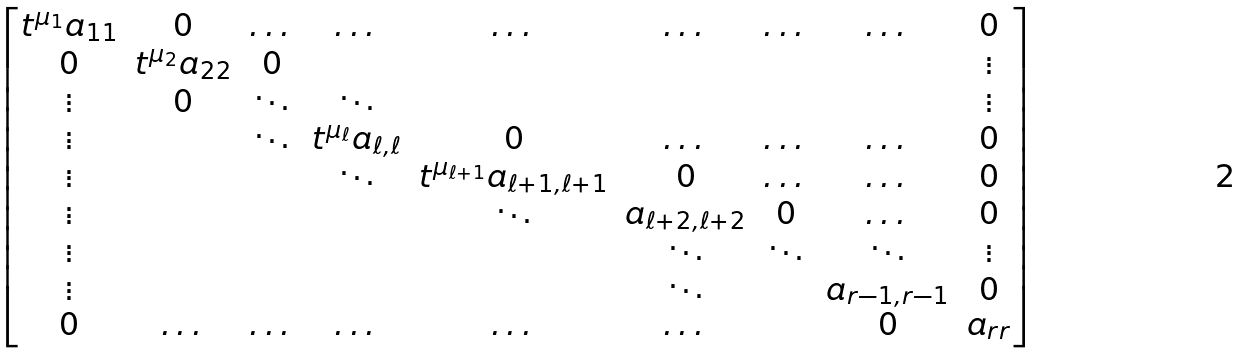<formula> <loc_0><loc_0><loc_500><loc_500>\begin{bmatrix} t ^ { \mu _ { 1 } } a _ { 1 1 } & 0 & \dots & \dots & \dots & \dots & \dots & \dots & 0 \\ 0 & t ^ { \mu _ { 2 } } a _ { 2 2 } & 0 & & & & & & \vdots \\ \vdots & 0 & \ddots & \ddots & & & & & \vdots \\ \vdots & & \ddots & t ^ { \mu _ { \ell } } a _ { \ell , \ell } & 0 & \dots & \dots & \dots & 0 \\ \vdots & & & \ddots & t ^ { \mu _ { \ell + 1 } } a _ { \ell + 1 , \ell + 1 } & 0 & \dots & \dots & 0 \\ \vdots & & & & \ddots & a _ { \ell + 2 , \ell + 2 } & 0 & \dots & 0 \\ \vdots & & & & & \ddots & \ddots & \ddots & \vdots \\ \vdots & & & & & \ddots & & a _ { r - 1 , r - 1 } & 0 \\ 0 & \dots & \dots & \dots & \dots & \dots & & 0 & a _ { r r } \end{bmatrix}</formula> 